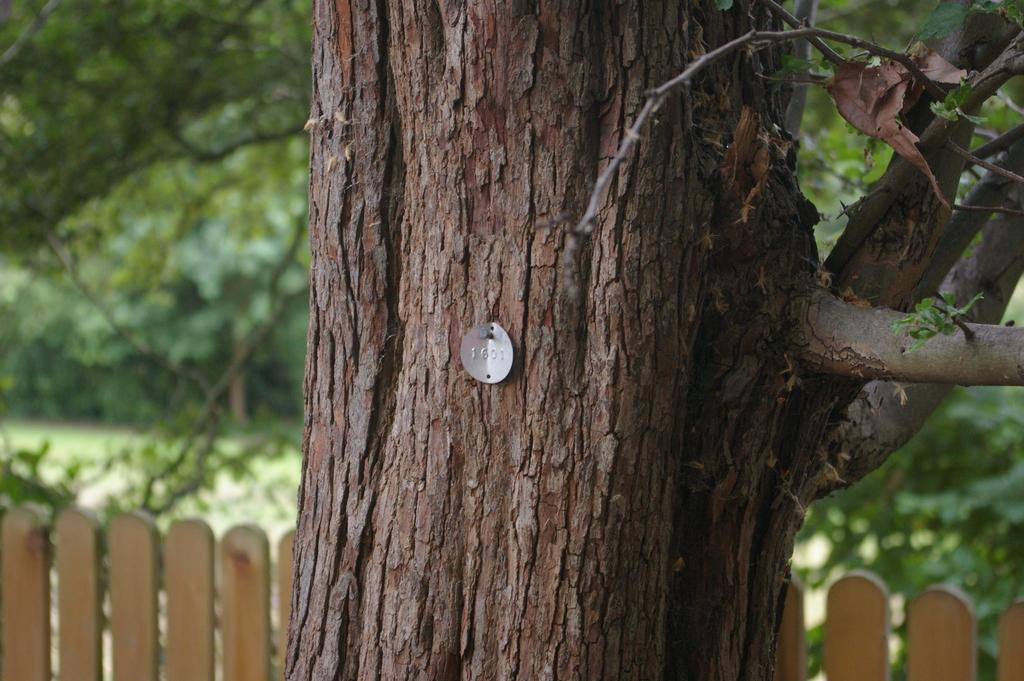What is the main subject of the image? The main subject of the image is a tree trunk with a batch. How would you describe the background of the image? The background of the image is blurred. What can be seen in the background of the image? There is a fence and trees visible in the background. What type of meal is being prepared on the tree trunk in the image? There is no meal being prepared in the image; it features a tree trunk with a batch. What operation is being performed on the tree trunk in the image? There is no operation being performed on the tree trunk in the image; it simply has a batch on it. 